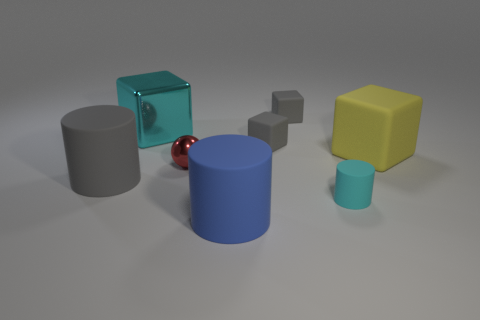Subtract all yellow rubber blocks. How many blocks are left? 3 Add 2 rubber objects. How many objects exist? 10 Subtract all red cubes. Subtract all green cylinders. How many cubes are left? 4 Subtract all balls. How many objects are left? 7 Subtract all rubber objects. Subtract all big gray objects. How many objects are left? 1 Add 5 small blocks. How many small blocks are left? 7 Add 5 yellow metal cylinders. How many yellow metal cylinders exist? 5 Subtract 0 red cubes. How many objects are left? 8 